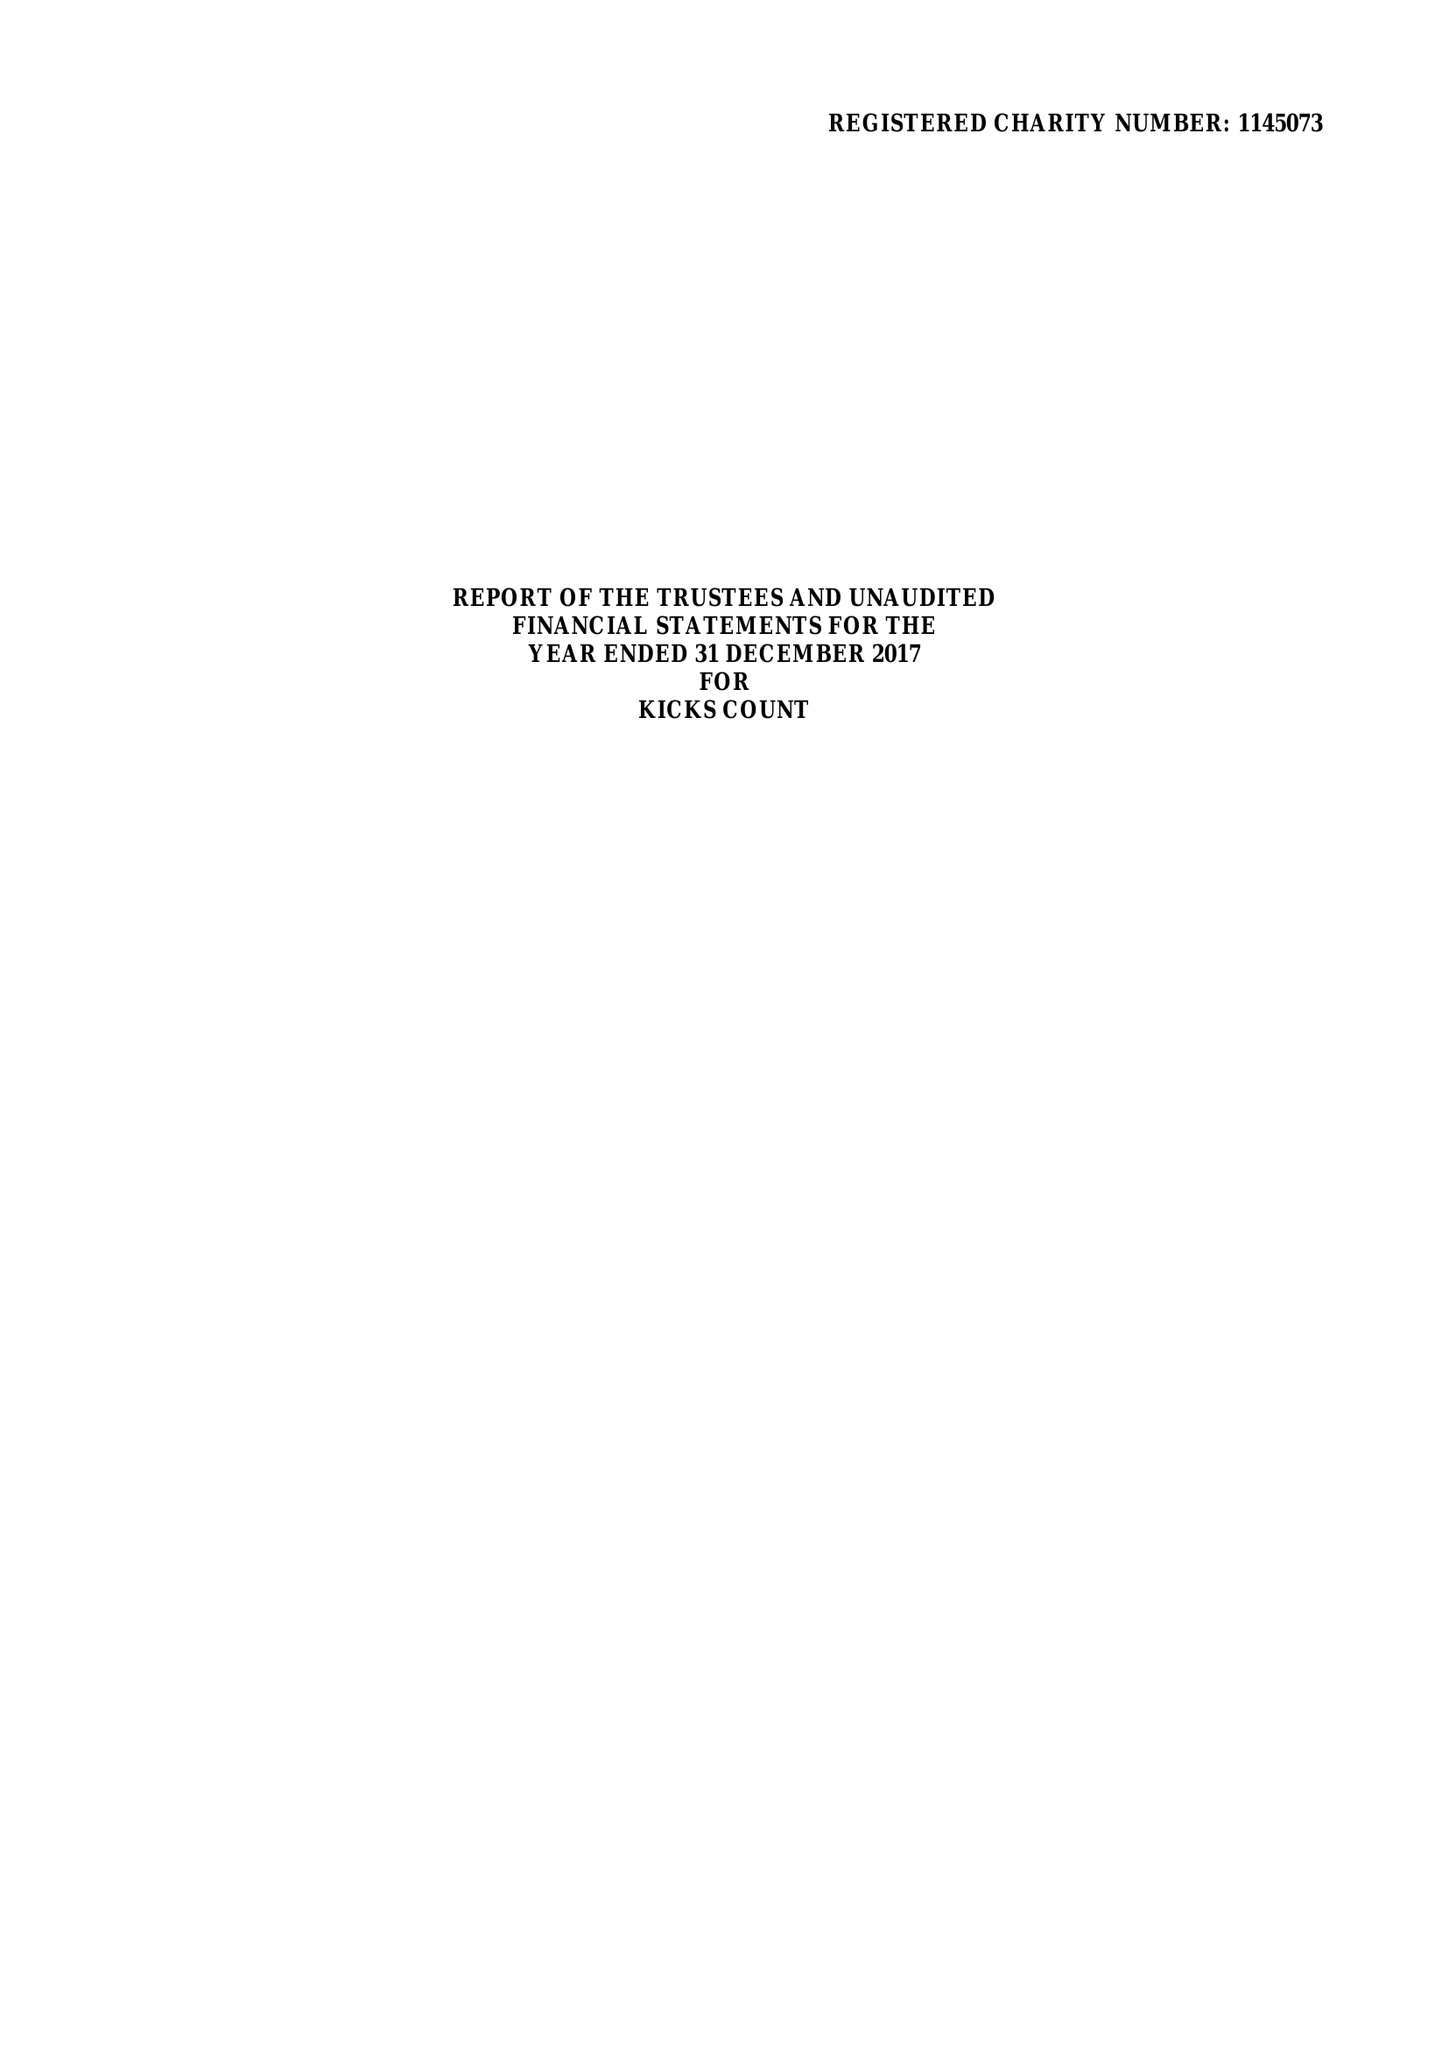What is the value for the report_date?
Answer the question using a single word or phrase. 2017-12-31 